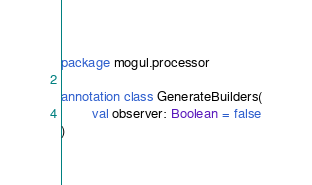Convert code to text. <code><loc_0><loc_0><loc_500><loc_500><_Kotlin_>package mogul.processor

annotation class GenerateBuilders(
        val observer: Boolean = false
)
</code> 